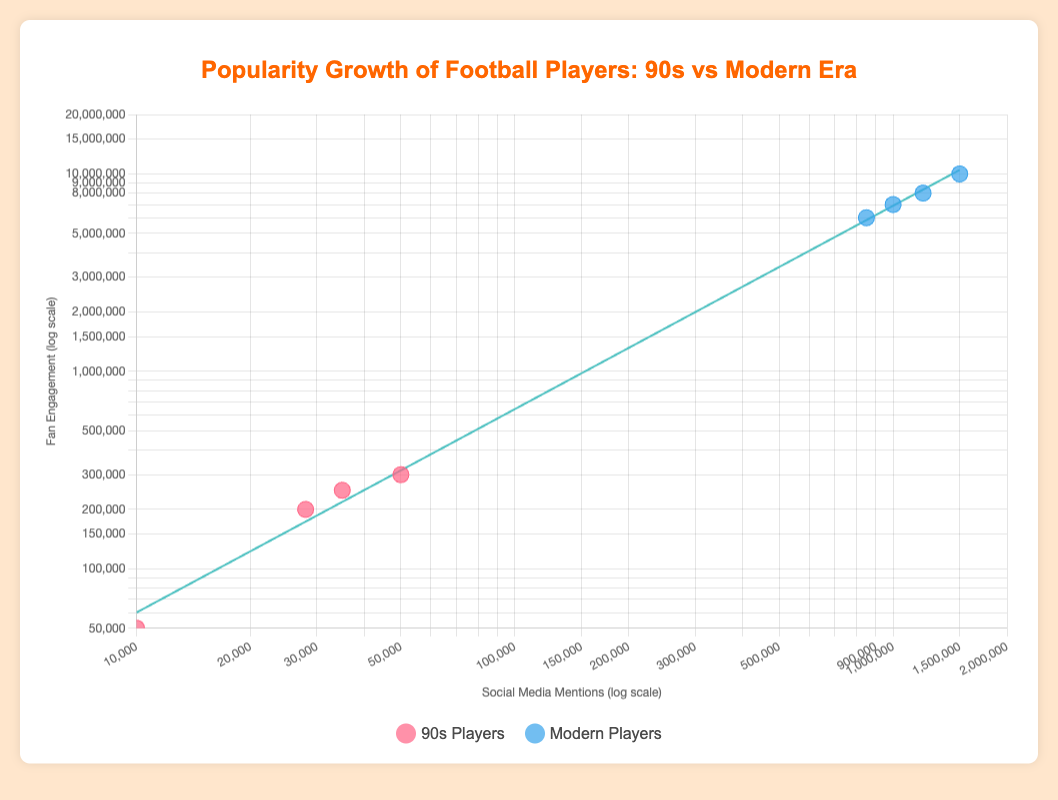What are the colors used for representing players from the 90s and modern era? The legend indicates that players from the 90s are represented by a pinkish-red color, while modern players are represented by a bluish color.
Answer: Pinkish-red for 90s, bluish for modern What is the range of the x-axis and the y-axis? The x-axis, representing social media mentions, ranges from 10,000 to 2,000,000, and the y-axis, representing fan engagement, ranges from 50,000 to 20,000,000.
Answer: 10,000 to 2,000,000 (x-axis), 50,000 to 20,000,000 (y-axis) Which player has the highest social media mentions and fan engagement in the modern era? Cristiano Ronaldo is shown with the highest social media mentions (1,500,000) and fan engagement (10,000,000) among modern players.
Answer: Cristiano Ronaldo Among 90s players, who has the least social media mentions and fan engagement? Wilson Mano has the least social media mentions and fan engagement at 10,000 and 50,000 respectively, among the 90s players.
Answer: Wilson Mano How does Neymar's social media mentions and fan engagement compare with Rivaldo's? Neymar has significantly higher social media mentions (1,000,000) and fan engagement (7,000,000) compared to Rivaldo's 28,000 mentions and 200,000 engagements.
Answer: Neymar has much higher values What does the trend line in the scatter plot represent? The trend line represents the general relationship and trend between social media mentions and fan engagement across all players, indicating that more mentions generally correspond to higher engagement.
Answer: Relationship between mentions and engagement Which era's players show a steeper increase in fan engagement with increasing social media mentions? Comparing the scatter points, modern players show a much steeper increase in fan engagement with increasing social media mentions compared to 90s players, as visible with points clustered higher in the modern era.
Answer: Modern era Calculate the average social media mentions for 90s and modern players respectively. For 90s players: (50,000 + 35,000 + 10,000 + 28,000) / 4 = 30,750. For modern players: (1,000,000 + 850,000 + 1,200,000 + 1,500,000) / 4 = 1,137,500.
Answer: 30,750 (90s), 1,137,500 (Modern) Determine the slope of the trend line representing the generalized relationship. Using the given formula, the slope is calculated based on the logarithmic values of social media mentions and fan engagement across all players. The specific numeric slope is derived from regression analysis.
Answer: Calculated from regression analysis 